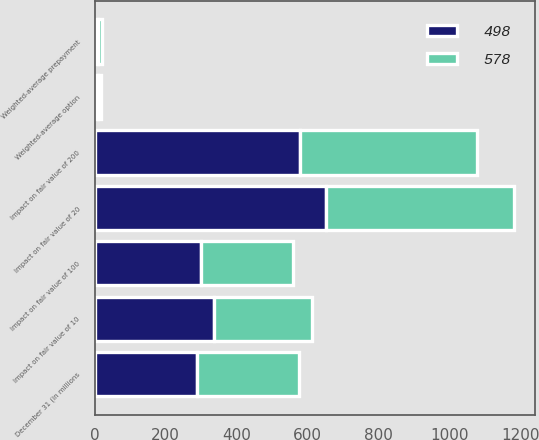Convert chart to OTSL. <chart><loc_0><loc_0><loc_500><loc_500><stacked_bar_chart><ecel><fcel>December 31 (in millions<fcel>Weighted-average prepayment<fcel>Impact on fair value of 10<fcel>Impact on fair value of 20<fcel>Weighted-average option<fcel>Impact on fair value of 100<fcel>Impact on fair value of 200<nl><fcel>578<fcel>287.5<fcel>9.81<fcel>275<fcel>529<fcel>9.02<fcel>258<fcel>498<nl><fcel>498<fcel>287.5<fcel>9.8<fcel>337<fcel>652<fcel>9.43<fcel>300<fcel>578<nl></chart> 